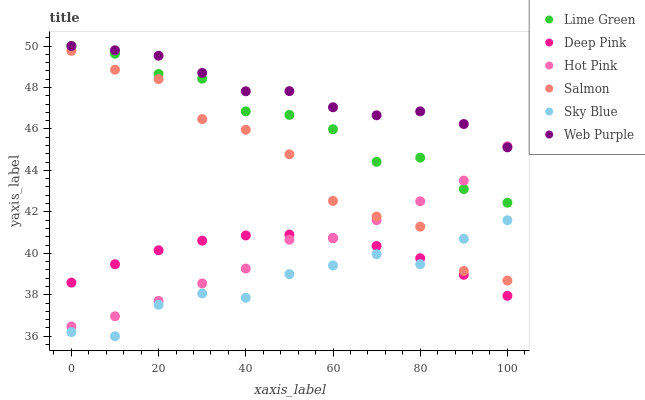Does Sky Blue have the minimum area under the curve?
Answer yes or no. Yes. Does Web Purple have the maximum area under the curve?
Answer yes or no. Yes. Does Hot Pink have the minimum area under the curve?
Answer yes or no. No. Does Hot Pink have the maximum area under the curve?
Answer yes or no. No. Is Deep Pink the smoothest?
Answer yes or no. Yes. Is Salmon the roughest?
Answer yes or no. Yes. Is Hot Pink the smoothest?
Answer yes or no. No. Is Hot Pink the roughest?
Answer yes or no. No. Does Sky Blue have the lowest value?
Answer yes or no. Yes. Does Hot Pink have the lowest value?
Answer yes or no. No. Does Lime Green have the highest value?
Answer yes or no. Yes. Does Hot Pink have the highest value?
Answer yes or no. No. Is Sky Blue less than Web Purple?
Answer yes or no. Yes. Is Hot Pink greater than Sky Blue?
Answer yes or no. Yes. Does Web Purple intersect Hot Pink?
Answer yes or no. Yes. Is Web Purple less than Hot Pink?
Answer yes or no. No. Is Web Purple greater than Hot Pink?
Answer yes or no. No. Does Sky Blue intersect Web Purple?
Answer yes or no. No. 